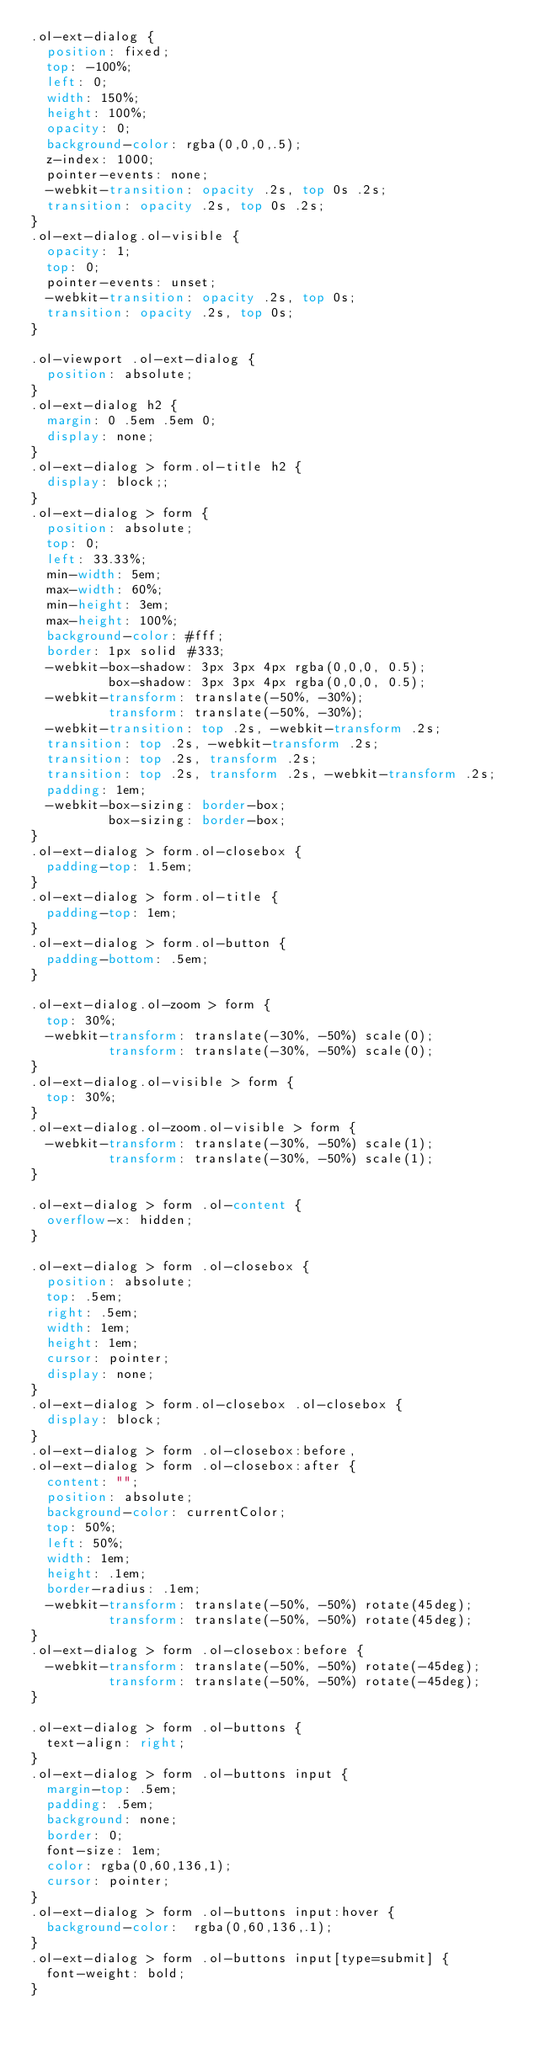Convert code to text. <code><loc_0><loc_0><loc_500><loc_500><_CSS_>.ol-ext-dialog {
  position: fixed;
  top: -100%;
  left: 0;
  width: 150%;
  height: 100%;
  opacity: 0;
  background-color: rgba(0,0,0,.5);
  z-index: 1000;
  pointer-events: none;
  -webkit-transition: opacity .2s, top 0s .2s;
  transition: opacity .2s, top 0s .2s;
}
.ol-ext-dialog.ol-visible {
  opacity: 1;
  top: 0;
  pointer-events: unset;
  -webkit-transition: opacity .2s, top 0s;
  transition: opacity .2s, top 0s;
}

.ol-viewport .ol-ext-dialog {
  position: absolute;
}
.ol-ext-dialog h2 {
  margin: 0 .5em .5em 0;
  display: none;
}
.ol-ext-dialog > form.ol-title h2 {
  display: block;;
}
.ol-ext-dialog > form {
  position: absolute;
  top: 0;
  left: 33.33%;
  min-width: 5em;
  max-width: 60%;
  min-height: 3em;
  max-height: 100%;
  background-color: #fff;
  border: 1px solid #333;
  -webkit-box-shadow: 3px 3px 4px rgba(0,0,0, 0.5);
          box-shadow: 3px 3px 4px rgba(0,0,0, 0.5);
  -webkit-transform: translate(-50%, -30%);
          transform: translate(-50%, -30%);
  -webkit-transition: top .2s, -webkit-transform .2s;
  transition: top .2s, -webkit-transform .2s;
  transition: top .2s, transform .2s;
  transition: top .2s, transform .2s, -webkit-transform .2s;
  padding: 1em;
  -webkit-box-sizing: border-box;
          box-sizing: border-box;
}
.ol-ext-dialog > form.ol-closebox {
  padding-top: 1.5em;
}
.ol-ext-dialog > form.ol-title {
  padding-top: 1em;
}
.ol-ext-dialog > form.ol-button {
  padding-bottom: .5em;
}

.ol-ext-dialog.ol-zoom > form {
  top: 30%;
  -webkit-transform: translate(-30%, -50%) scale(0);
          transform: translate(-30%, -50%) scale(0);
}
.ol-ext-dialog.ol-visible > form {
  top: 30%;
}
.ol-ext-dialog.ol-zoom.ol-visible > form {
  -webkit-transform: translate(-30%, -50%) scale(1);
          transform: translate(-30%, -50%) scale(1);
}

.ol-ext-dialog > form .ol-content {
  overflow-x: hidden;
}

.ol-ext-dialog > form .ol-closebox {
  position: absolute;
  top: .5em;
  right: .5em;
  width: 1em;
  height: 1em;
  cursor: pointer;
  display: none;
}
.ol-ext-dialog > form.ol-closebox .ol-closebox {
  display: block;
}
.ol-ext-dialog > form .ol-closebox:before,
.ol-ext-dialog > form .ol-closebox:after {
  content: "";
  position: absolute;
  background-color: currentColor;
  top: 50%;
  left: 50%;
  width: 1em;
  height: .1em;
  border-radius: .1em;
  -webkit-transform: translate(-50%, -50%) rotate(45deg);
          transform: translate(-50%, -50%) rotate(45deg);
}
.ol-ext-dialog > form .ol-closebox:before {
  -webkit-transform: translate(-50%, -50%) rotate(-45deg);
          transform: translate(-50%, -50%) rotate(-45deg);
}

.ol-ext-dialog > form .ol-buttons {
  text-align: right;
}
.ol-ext-dialog > form .ol-buttons input {
  margin-top: .5em;
  padding: .5em;
  background: none;
  border: 0;
  font-size: 1em;
  color: rgba(0,60,136,1);
  cursor: pointer;
}
.ol-ext-dialog > form .ol-buttons input:hover {
  background-color:  rgba(0,60,136,.1);
}
.ol-ext-dialog > form .ol-buttons input[type=submit] {
  font-weight: bold;
}</code> 